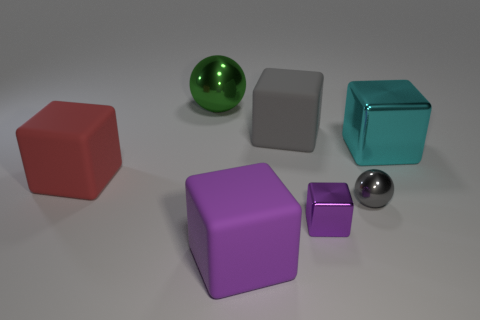What number of other objects are the same color as the small block?
Your answer should be compact. 1. There is a rubber cube behind the matte cube left of the rubber block that is in front of the tiny purple shiny object; what is its size?
Ensure brevity in your answer.  Large. The gray block that is the same material as the big purple thing is what size?
Ensure brevity in your answer.  Large. There is a big matte object that is behind the small gray sphere and in front of the big gray rubber block; what color is it?
Your response must be concise. Red. There is a big rubber thing that is behind the big cyan block; is it the same shape as the gray thing that is in front of the large red thing?
Provide a short and direct response. No. There is a gray thing that is behind the gray ball; what is it made of?
Ensure brevity in your answer.  Rubber. There is a cube that is the same color as the tiny shiny ball; what is its size?
Your answer should be very brief. Large. How many objects are either large rubber cubes that are in front of the small gray metallic thing or small green spheres?
Your answer should be compact. 1. Are there an equal number of large gray rubber things that are on the left side of the big purple thing and yellow metal blocks?
Give a very brief answer. Yes. Is the size of the gray shiny ball the same as the green ball?
Your answer should be compact. No. 